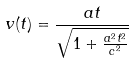<formula> <loc_0><loc_0><loc_500><loc_500>v ( t ) = { \frac { a t } { \sqrt { 1 + { \frac { a ^ { 2 } t ^ { 2 } } { c ^ { 2 } } } } } }</formula> 